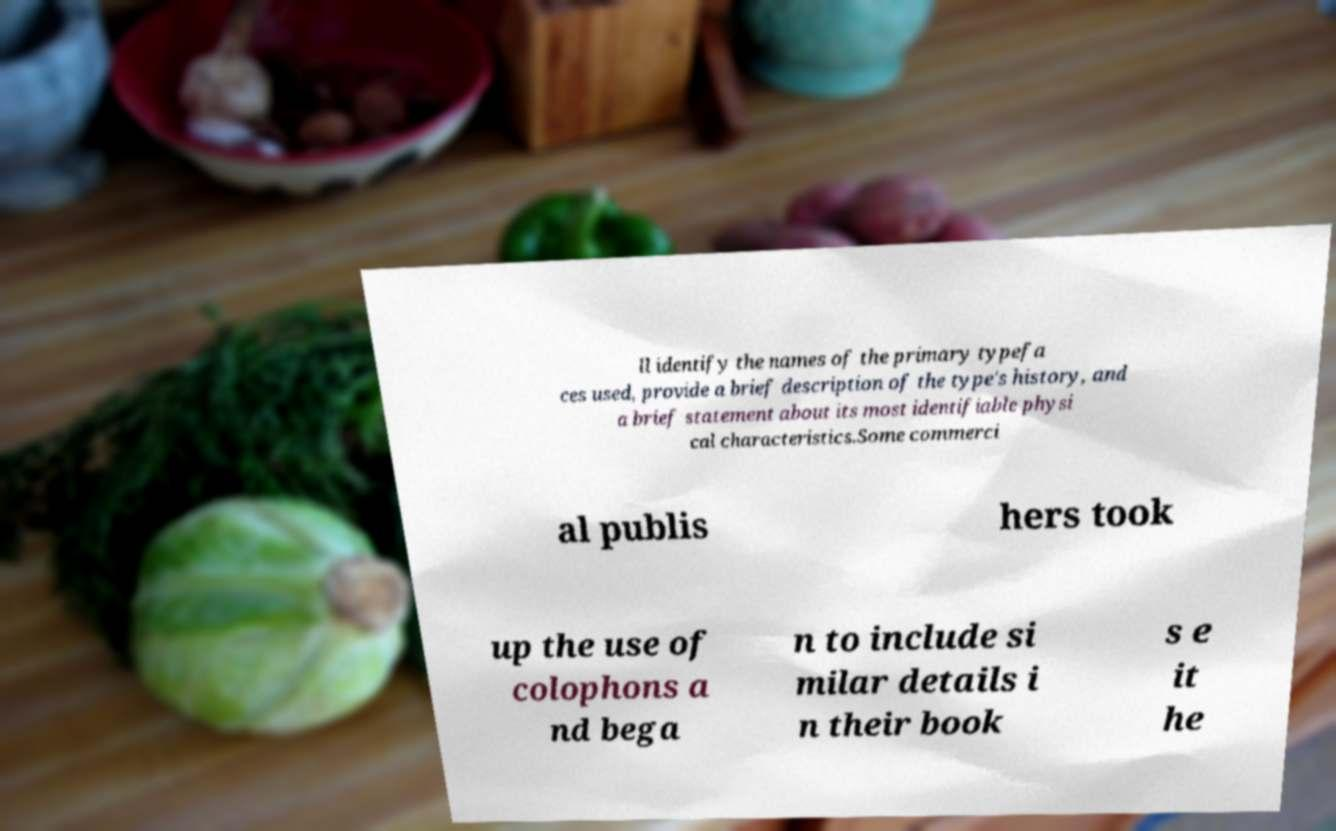Please read and relay the text visible in this image. What does it say? ll identify the names of the primary typefa ces used, provide a brief description of the type's history, and a brief statement about its most identifiable physi cal characteristics.Some commerci al publis hers took up the use of colophons a nd bega n to include si milar details i n their book s e it he 